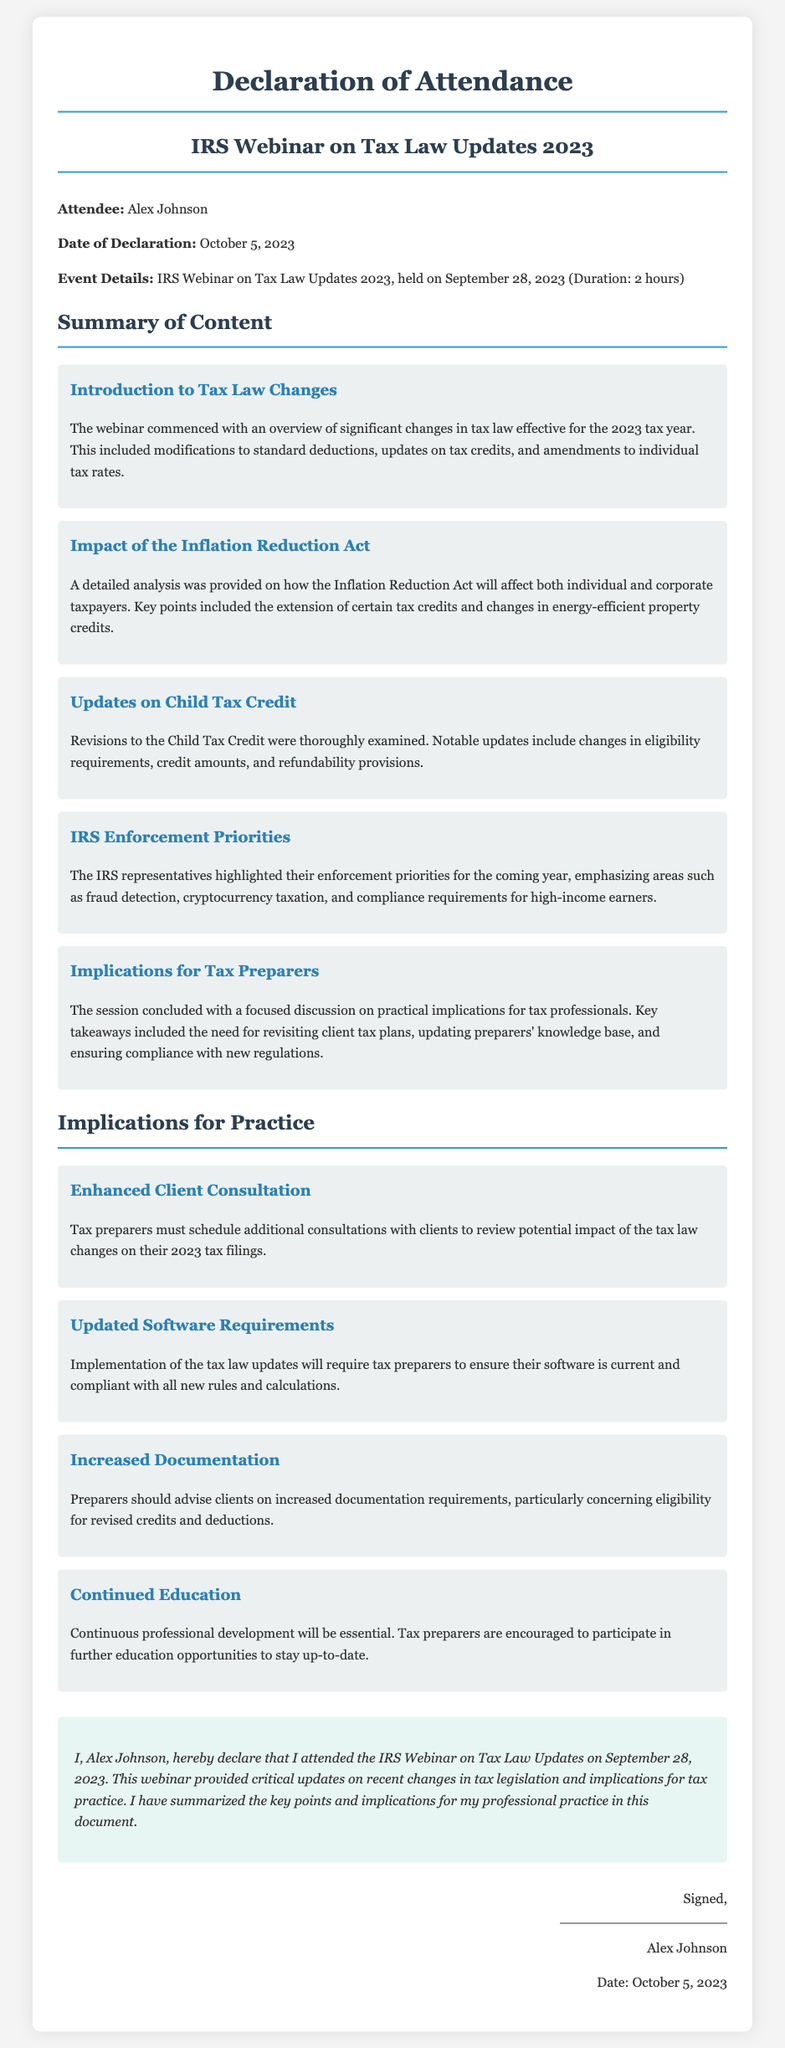What is the name of the attendee? The attendee's name is stated at the beginning of the document.
Answer: Alex Johnson What date was the webinar held? The date of the webinar is mentioned in the event details section.
Answer: September 28, 2023 How long was the webinar? The duration of the webinar is specified in the event details section.
Answer: 2 hours What act was discussed in relation to individual and corporate taxpayers? The specific act affecting taxpayers is noted in the summary of content.
Answer: Inflation Reduction Act What is one implication for tax preparers mentioned in the document? The implications for tax preparers are detailed in the section about implications for practice.
Answer: Enhanced Client Consultation Who signed the declaration? The name of the person who signed the declaration is provided at the end of the document.
Answer: Alex Johnson What is the date of the declaration? The date on which the declaration was made is mentioned in the signature section.
Answer: October 5, 2023 What is one of the updates mentioned regarding the Child Tax Credit? The updates on this credit include specifics found in the summary section.
Answer: Changes in eligibility requirements What type of document is this? The title and structure clearly define the nature of the document.
Answer: Declaration of Attendance 